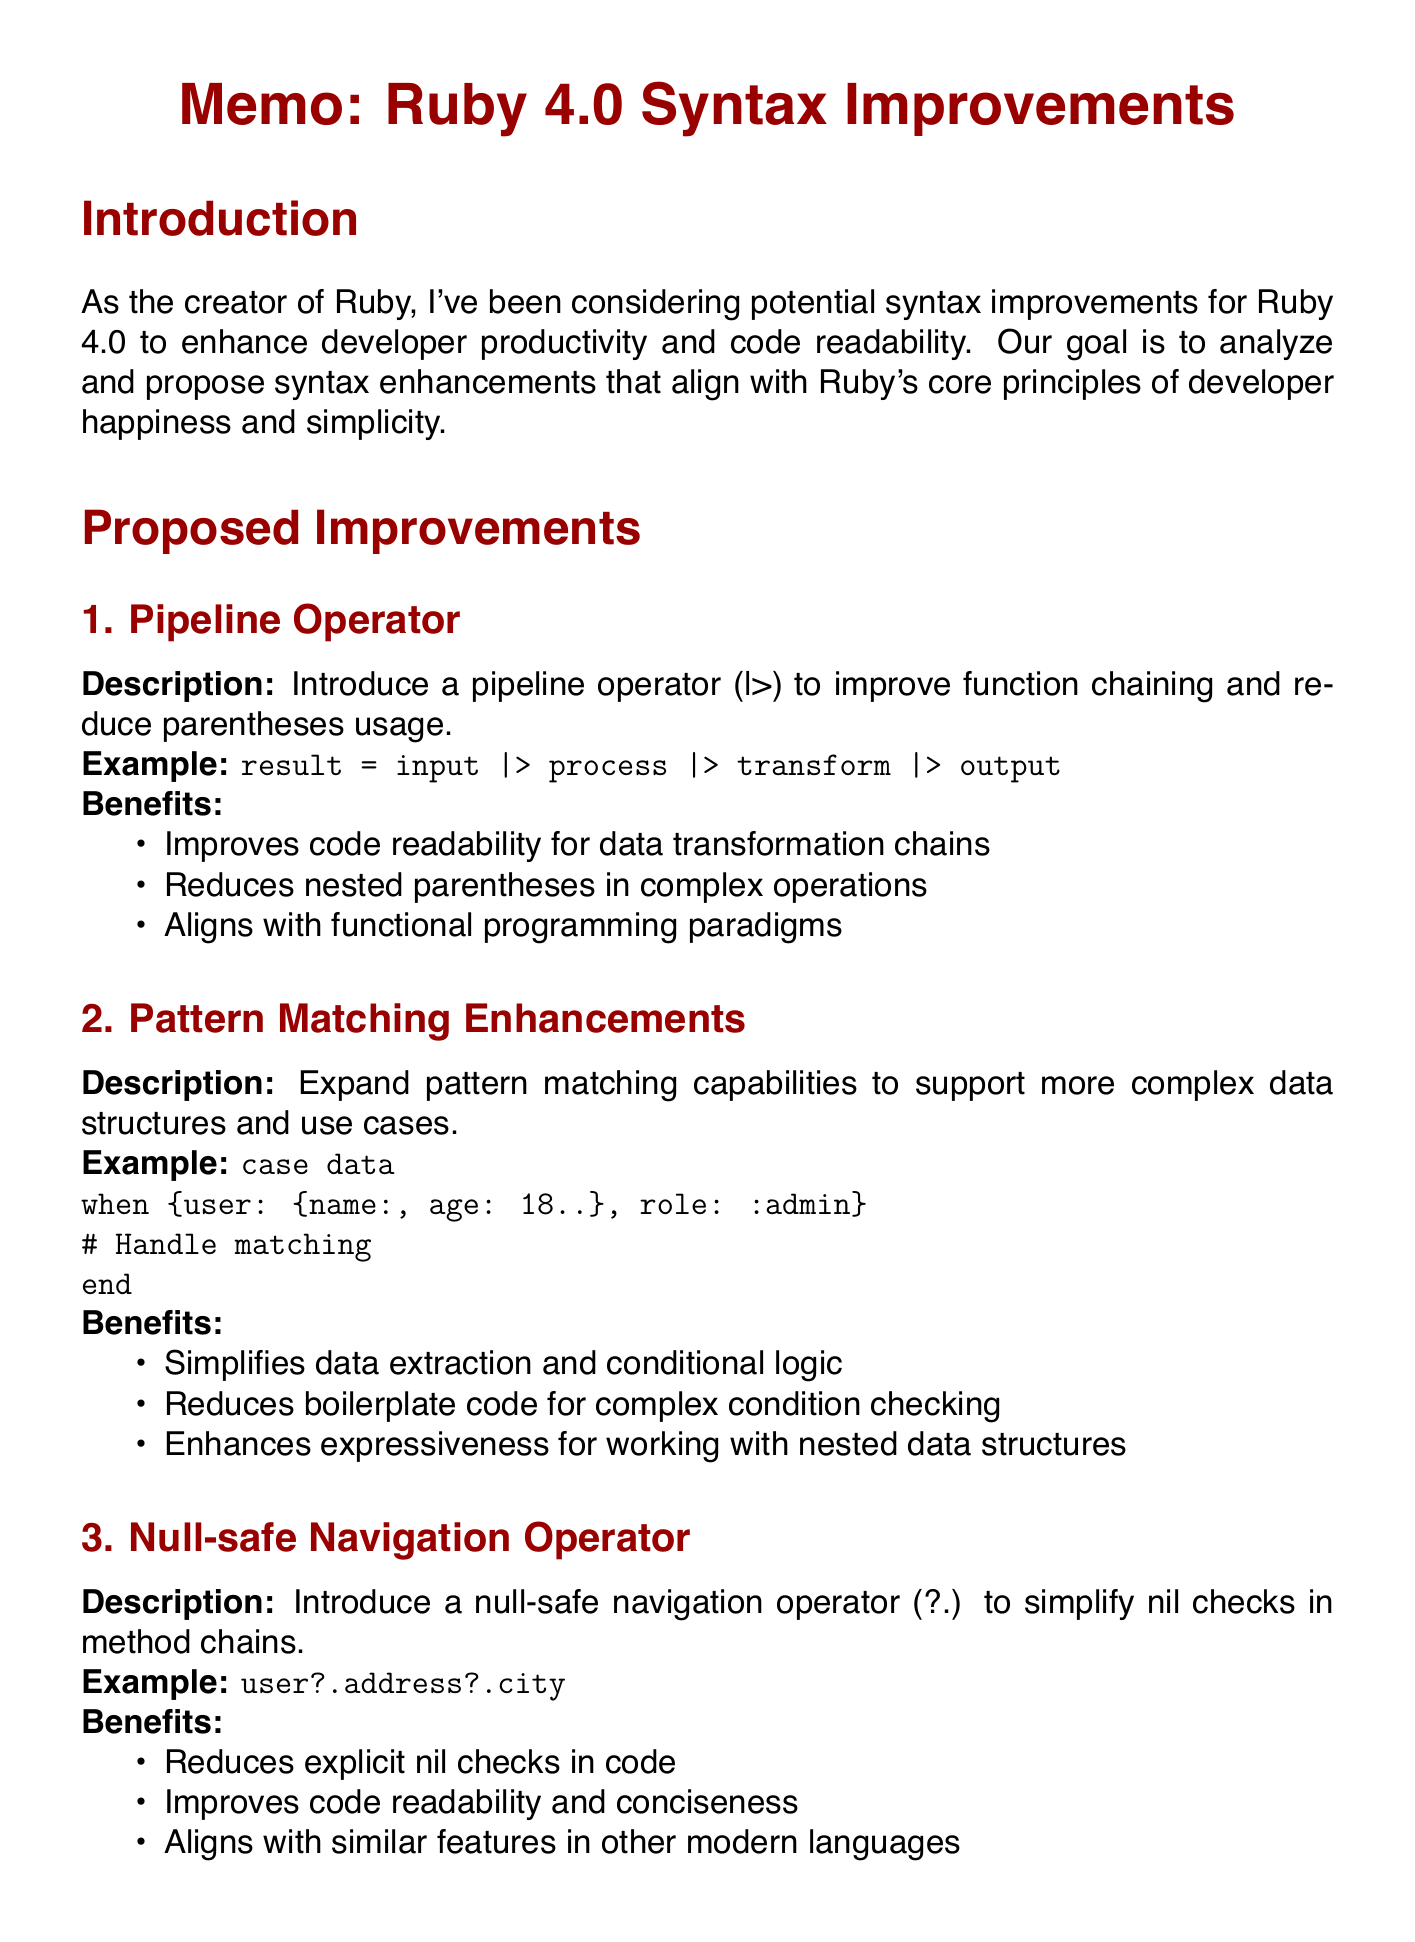What is the goal of the proposed syntax improvements? The goal is to analyze and propose syntax enhancements that align with Ruby's core principles of developer happiness and simplicity.
Answer: To enhance developer productivity and code readability What operator is being introduced to improve function chaining? The document mentions a specific operator that aims to reduce parentheses usage in function chaining.
Answer: Pipeline operator What is an example provided for the null-safe navigation operator? The document includes an example illustrating how the null-safe navigation operator is used in practice.
Answer: user?.address?.city What are the key concerns mentioned in the community feedback? The document lists several concerns raised by the community regarding new syntax features.
Answer: Maintaining simplicity and readability How many proposed improvements are outlined in the document? The document enumerates the proposed syntax enhancements, which indicates the number of items discussed.
Answer: Three What is the next step for each proposed syntax improvement? The document specifies a follow-up action that involves soliciting feedback to refine the proposals.
Answer: Develop detailed RFC What is the focus of the impact analysis section? This section addresses how the proposed syntax changes will affect existing Ruby code and performance.
Answer: Backwards compatibility What modern programming feature aligns with the proposed improvements? The document discusses how some of the new features relate to practices in other contemporary programming languages.
Answer: Null-safe navigation operator 